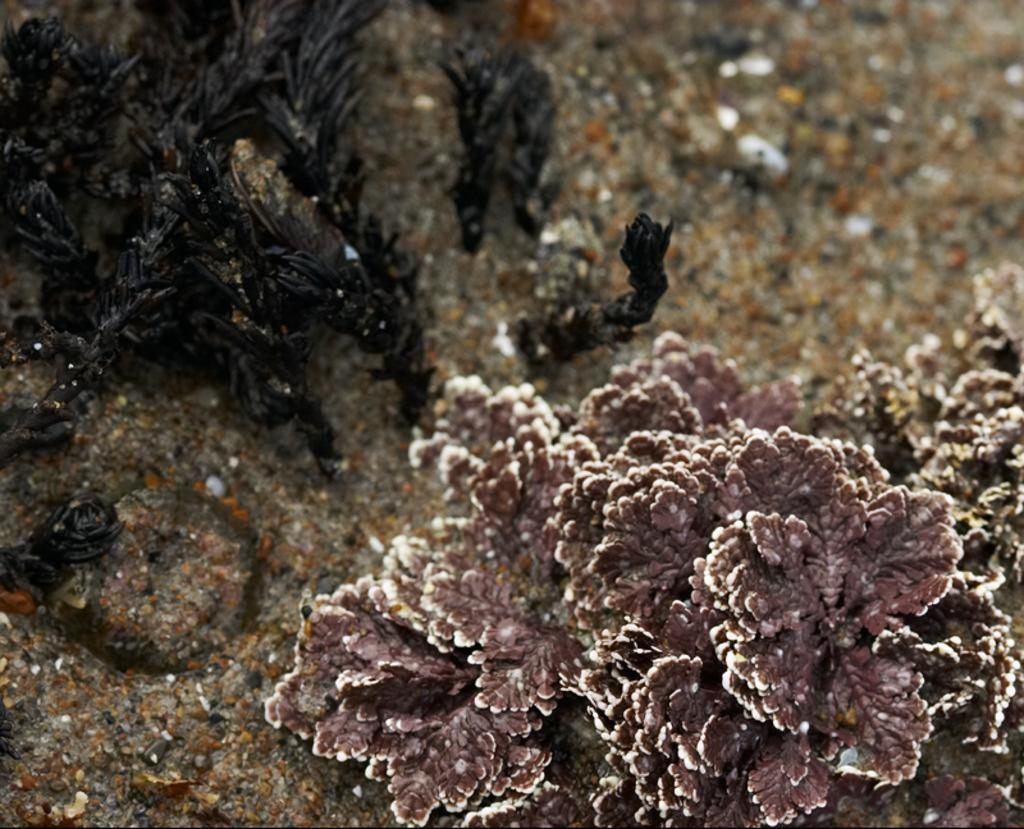What is located in the foreground of the image? There is a plant in the foreground of the image. What can be seen beside the plant? There is a black object beside the plant. What type of collar can be seen on the snail in the image? There is no snail present in the image, and therefore no collar can be seen. 